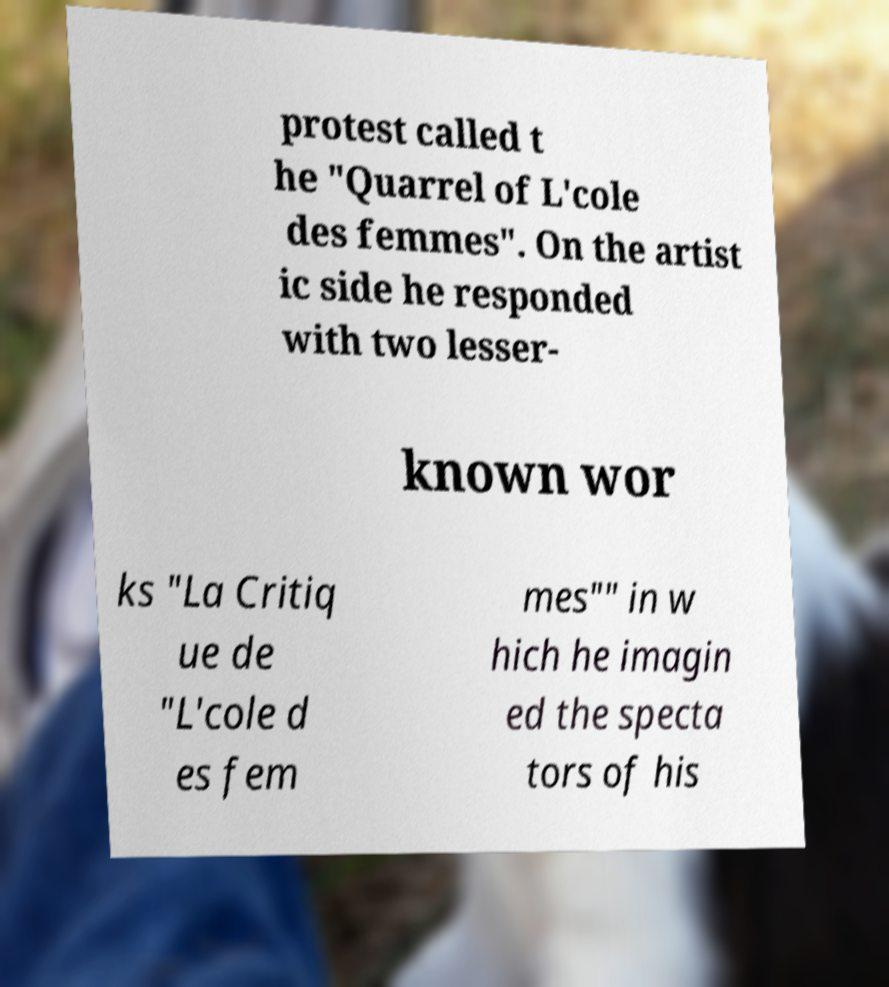There's text embedded in this image that I need extracted. Can you transcribe it verbatim? protest called t he "Quarrel of L'cole des femmes". On the artist ic side he responded with two lesser- known wor ks "La Critiq ue de "L'cole d es fem mes"" in w hich he imagin ed the specta tors of his 